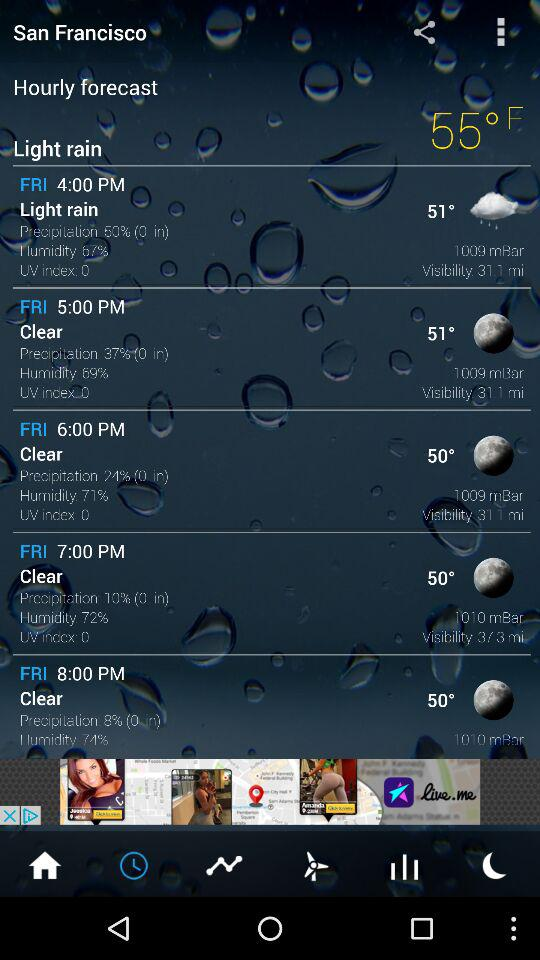What is the precipitation percentage at 6:00 pm? The precipitation was 24% at 6:00 pm. 